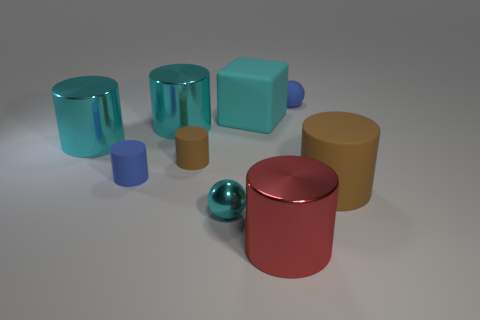There is another brown object that is the same shape as the large brown object; what material is it?
Your answer should be compact. Rubber. There is a cube that is the same color as the tiny shiny ball; what material is it?
Offer a very short reply. Rubber. Is the big block the same color as the tiny shiny object?
Make the answer very short. Yes. Is there anything else that has the same shape as the cyan matte thing?
Keep it short and to the point. No. Is the number of small metallic things less than the number of large red matte blocks?
Ensure brevity in your answer.  No. The large thing that is in front of the cyan metal thing that is in front of the large brown cylinder is what color?
Provide a succinct answer. Red. The tiny sphere in front of the brown matte cylinder in front of the brown object left of the small cyan ball is made of what material?
Offer a terse response. Metal. Is the size of the rubber cylinder on the right side of the matte block the same as the block?
Your answer should be compact. Yes. What is the material of the sphere left of the cyan rubber block?
Provide a short and direct response. Metal. Are there more tiny blue rubber cylinders than big cyan metallic objects?
Your response must be concise. No. 